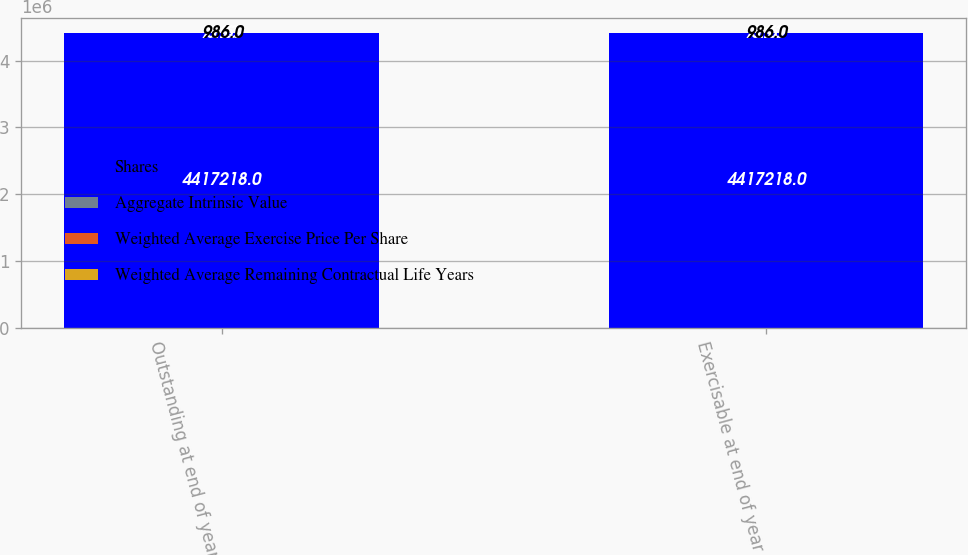Convert chart to OTSL. <chart><loc_0><loc_0><loc_500><loc_500><stacked_bar_chart><ecel><fcel>Outstanding at end of year<fcel>Exercisable at end of year<nl><fcel>Shares<fcel>4.41722e+06<fcel>4.41722e+06<nl><fcel>Aggregate Intrinsic Value<fcel>71.69<fcel>71.69<nl><fcel>Weighted Average Exercise Price Per Share<fcel>3.93<fcel>3.93<nl><fcel>Weighted Average Remaining Contractual Life Years<fcel>986<fcel>986<nl></chart> 